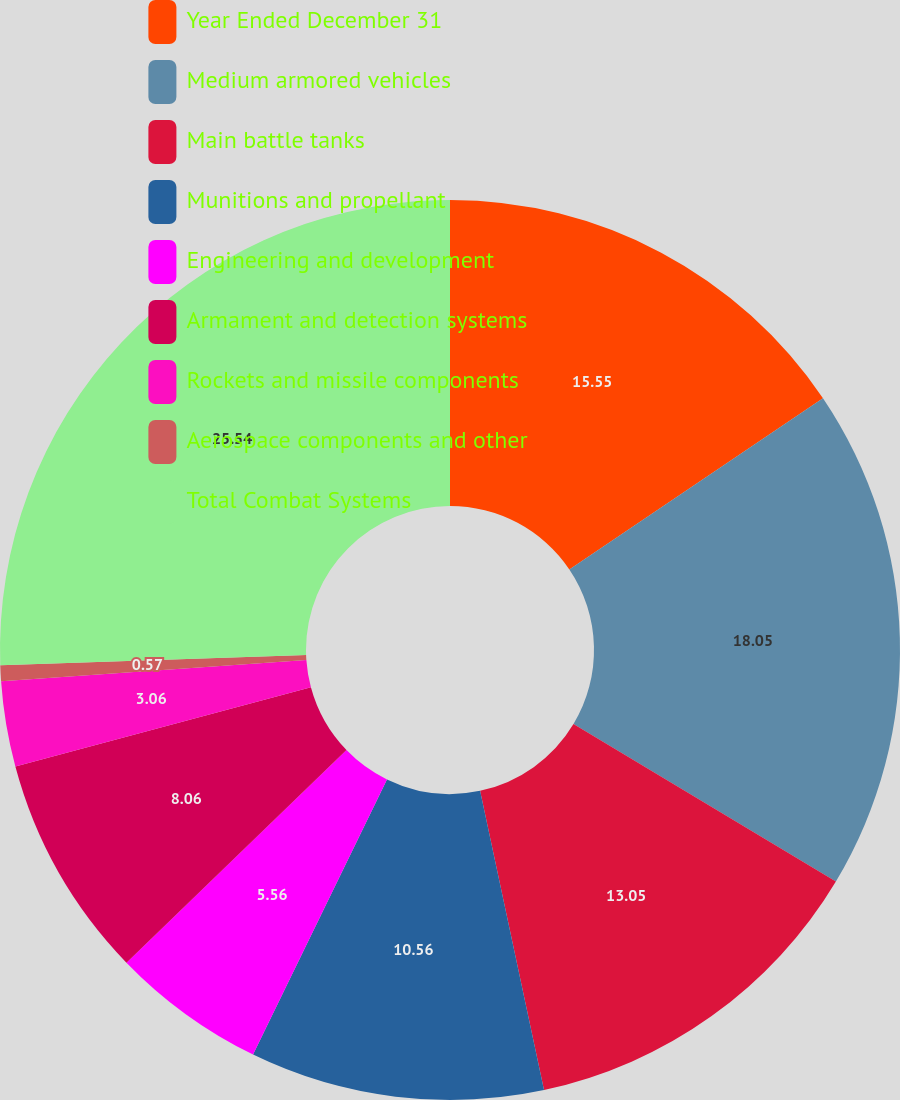<chart> <loc_0><loc_0><loc_500><loc_500><pie_chart><fcel>Year Ended December 31<fcel>Medium armored vehicles<fcel>Main battle tanks<fcel>Munitions and propellant<fcel>Engineering and development<fcel>Armament and detection systems<fcel>Rockets and missile components<fcel>Aerospace components and other<fcel>Total Combat Systems<nl><fcel>15.55%<fcel>18.05%<fcel>13.05%<fcel>10.56%<fcel>5.56%<fcel>8.06%<fcel>3.06%<fcel>0.57%<fcel>25.54%<nl></chart> 